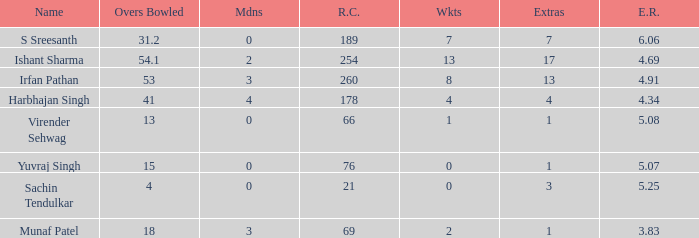Name the runs conceded where overs bowled is 53 1.0. 